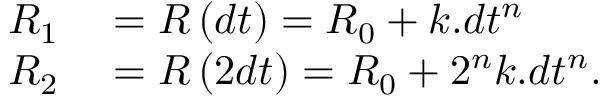Convert formula to latex. <formula><loc_0><loc_0><loc_500><loc_500>\begin{array} { r } { \begin{array} { r l } { R _ { 1 } } & = R \left ( d t \right ) = R _ { 0 } + k . d t ^ { n } } \\ { R _ { 2 } } & = R \left ( 2 d t \right ) = R _ { 0 } + 2 ^ { n } k . d t ^ { n } . } \end{array} } \end{array}</formula> 